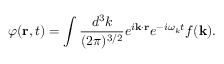<formula> <loc_0><loc_0><loc_500><loc_500>\varphi ( { r } , t ) = \int \frac { d ^ { 3 } k } { ( 2 \pi ) ^ { 3 / 2 } } e ^ { i { k } \cdot { r } } e ^ { - i \omega _ { k } t } f ( { k } ) .</formula> 